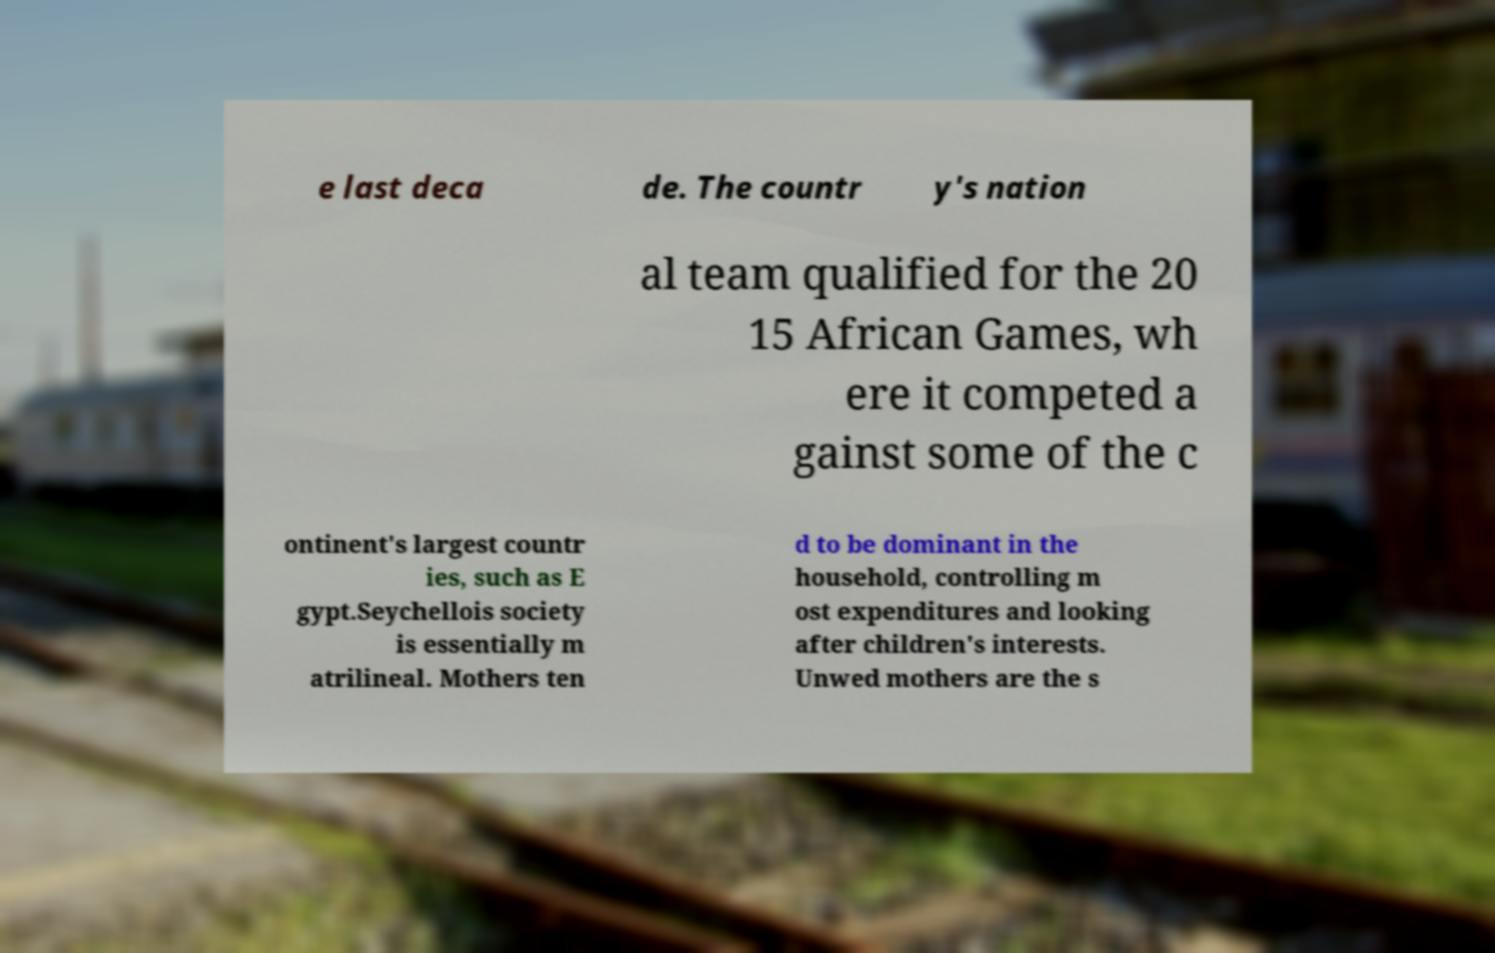For documentation purposes, I need the text within this image transcribed. Could you provide that? e last deca de. The countr y's nation al team qualified for the 20 15 African Games, wh ere it competed a gainst some of the c ontinent's largest countr ies, such as E gypt.Seychellois society is essentially m atrilineal. Mothers ten d to be dominant in the household, controlling m ost expenditures and looking after children's interests. Unwed mothers are the s 